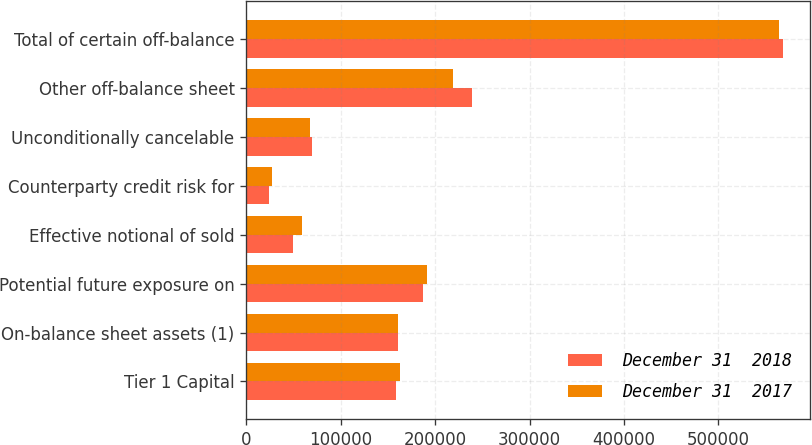Convert chart to OTSL. <chart><loc_0><loc_0><loc_500><loc_500><stacked_bar_chart><ecel><fcel>Tier 1 Capital<fcel>On-balance sheet assets (1)<fcel>Potential future exposure on<fcel>Effective notional of sold<fcel>Counterparty credit risk for<fcel>Unconditionally cancelable<fcel>Other off-balance sheet<fcel>Total of certain off-balance<nl><fcel>December 31  2018<fcel>158122<fcel>160250<fcel>187130<fcel>49402<fcel>23715<fcel>69630<fcel>238805<fcel>568682<nl><fcel>December 31  2017<fcel>162377<fcel>160250<fcel>191555<fcel>59207<fcel>27005<fcel>67644<fcel>218754<fcel>564165<nl></chart> 